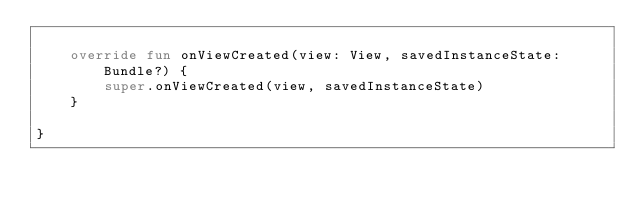Convert code to text. <code><loc_0><loc_0><loc_500><loc_500><_Kotlin_>
    override fun onViewCreated(view: View, savedInstanceState: Bundle?) {
        super.onViewCreated(view, savedInstanceState)
    }

}</code> 